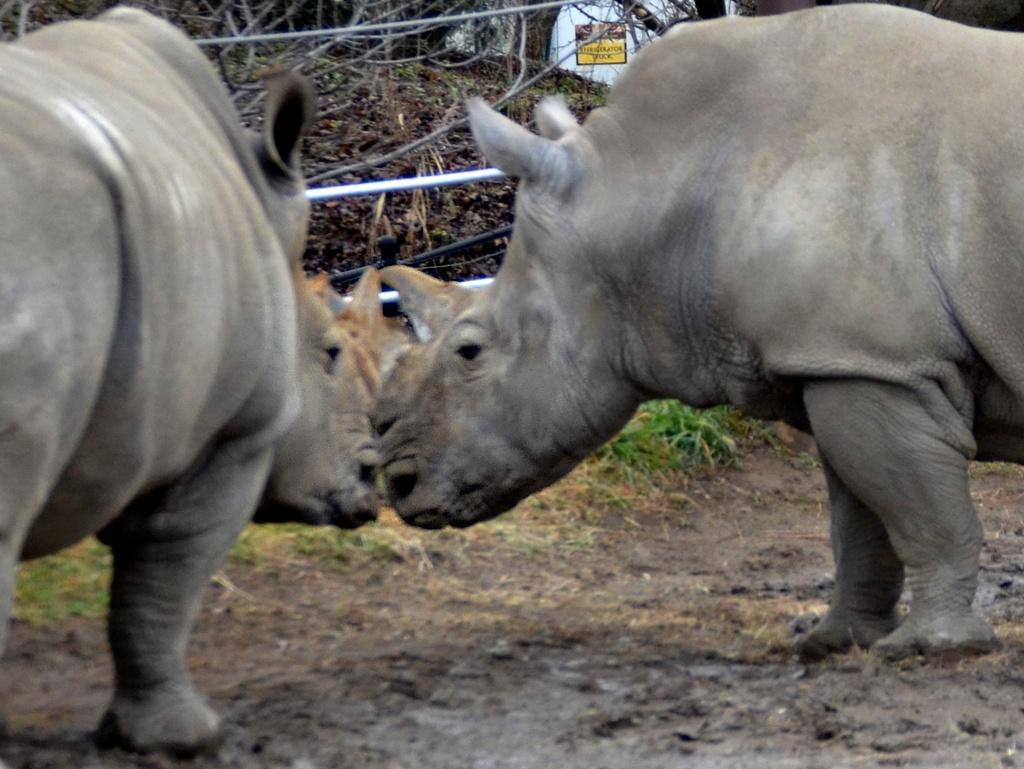How would you summarize this image in a sentence or two? In this image I can see two animals which are in black color. In the background I can see the plants and the board. 